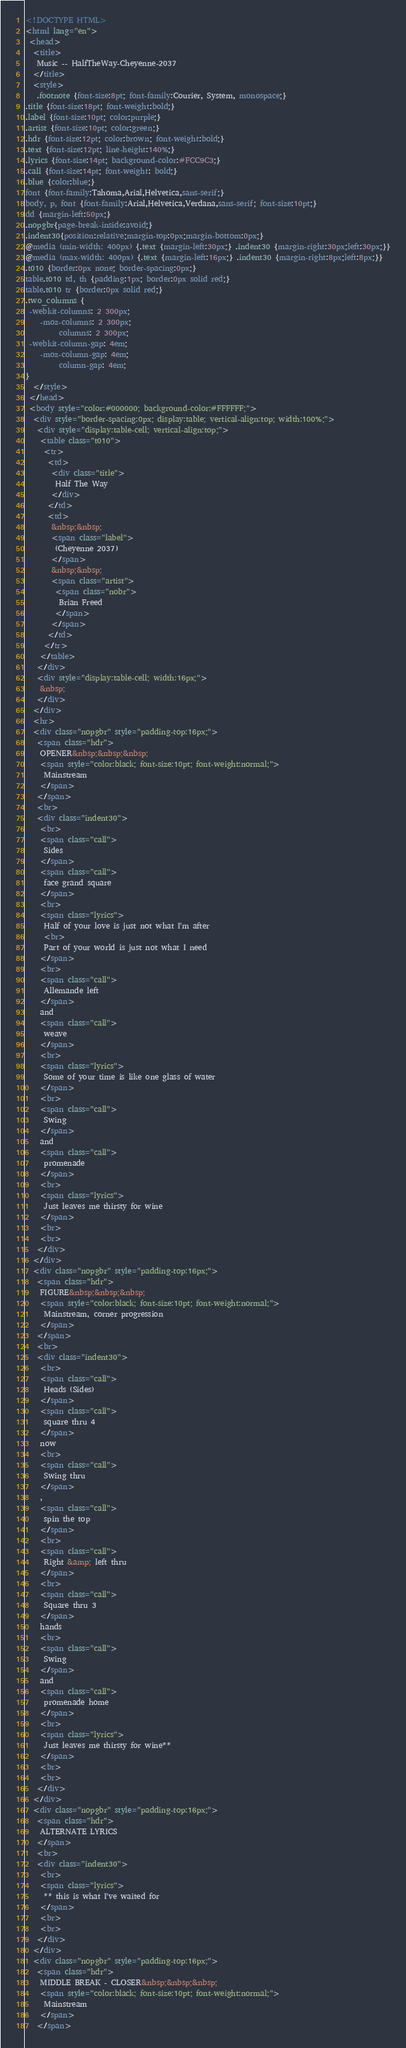Convert code to text. <code><loc_0><loc_0><loc_500><loc_500><_HTML_><!DOCTYPE HTML>
<html lang="en">
 <head>
  <title>
   Music -- HalfTheWay-Cheyenne-2037
  </title>
  <style>
   .footnote {font-size:8pt; font-family:Courier, System, monospace;}
.title {font-size:18pt; font-weight:bold;}
.label {font-size:10pt; color:purple;}
.artist {font-size:10pt; color:green;}
.hdr {font-size:12pt; color:brown; font-weight:bold;}
.text {font-size:12pt; line-height:140%;}
.lyrics {font-size:14pt; background-color:#FCC9C3;}
.call {font-size:14pt; font-weight: bold;}
.blue {color:blue;}
font {font-family:Tahoma,Arial,Helvetica,sans-serif;}
body, p, font {font-family:Arial,Helvetica,Verdana,sans-serif; font-size:10pt;}
dd {margin-left:50px;}
.nopgbr{page-break-inside:avoid;}
.indent30{position:relative;margin-top:0px;margin-bottom:0px;}
@media (min-width: 400px) {.text {margin-left:30px;} .indent30 {margin-right:30px;left:30px;}}
@media (max-width: 400px) {.text {margin-left:16px;} .indent30 {margin-right:8px;left:8px;}}
.t010 {border:0px none; border-spacing:0px;}
table.t010 td, th {padding:1px; border:0px solid red;}
table.t010 tr {border:0px solid red;}
.two_columns {
 -webkit-columns: 2 300px;
    -moz-columns: 2 300px;
         columns: 2 300px;
 -webkit-column-gap: 4em;
    -moz-column-gap: 4em;
         column-gap: 4em;
}
  </style>
 </head>
 <body style="color:#000000; background-color:#FFFFFF;">
  <div style="border-spacing:0px; display:table; vertical-align:top; width:100%;">
   <div style="display:table-cell; vertical-align:top;">
    <table class="t010">
     <tr>
      <td>
       <div class="title">
        Half The Way
       </div>
      </td>
      <td>
       &nbsp;&nbsp;
       <span class="label">
        (Cheyenne 2037)
       </span>
       &nbsp;&nbsp;
       <span class="artist">
        <span class="nobr">
         Brian Freed
        </span>
       </span>
      </td>
     </tr>
    </table>
   </div>
   <div style="display:table-cell; width:16px;">
    &nbsp;
   </div>
  </div>
  <hr>
  <div class="nopgbr" style="padding-top:16px;">
   <span class="hdr">
    OPENER&nbsp;&nbsp;&nbsp;
    <span style="color:black; font-size:10pt; font-weight:normal;">
     Mainstream
    </span>
   </span>
   <br>
   <div class="indent30">
    <br>
    <span class="call">
     Sides
    </span>
    <span class="call">
     face grand square
    </span>
    <br>
    <span class="lyrics">
     Half of your love is just not what I'm after
     <br>
     Part of your world is just not what I need
    </span>
    <br>
    <span class="call">
     Allemande left
    </span>
    and
    <span class="call">
     weave
    </span>
    <br>
    <span class="lyrics">
     Some of your time is like one glass of water
    </span>
    <br>
    <span class="call">
     Swing
    </span>
    and
    <span class="call">
     promenade
    </span>
    <br>
    <span class="lyrics">
     Just leaves me thirsty for wine
    </span>
    <br>
    <br>
   </div>
  </div>
  <div class="nopgbr" style="padding-top:16px;">
   <span class="hdr">
    FIGURE&nbsp;&nbsp;&nbsp;
    <span style="color:black; font-size:10pt; font-weight:normal;">
     Mainstream, corner progression
    </span>
   </span>
   <br>
   <div class="indent30">
    <br>
    <span class="call">
     Heads (Sides)
    </span>
    <span class="call">
     square thru 4
    </span>
    now
    <br>
    <span class="call">
     Swing thru
    </span>
    ,
    <span class="call">
     spin the top
    </span>
    <br>
    <span class="call">
     Right &amp; left thru
    </span>
    <br>
    <span class="call">
     Square thru 3
    </span>
    hands
    <br>
    <span class="call">
     Swing
    </span>
    and
    <span class="call">
     promenade home
    </span>
    <br>
    <span class="lyrics">
     Just leaves me thirsty for wine**
    </span>
    <br>
    <br>
   </div>
  </div>
  <div class="nopgbr" style="padding-top:16px;">
   <span class="hdr">
    ALTERNATE LYRICS
   </span>
   <br>
   <div class="indent30">
    <br>
    <span class="lyrics">
     ** this is what I've waited for
    </span>
    <br>
    <br>
   </div>
  </div>
  <div class="nopgbr" style="padding-top:16px;">
   <span class="hdr">
    MIDDLE BREAK - CLOSER&nbsp;&nbsp;&nbsp;
    <span style="color:black; font-size:10pt; font-weight:normal;">
     Mainstream
    </span>
   </span></code> 